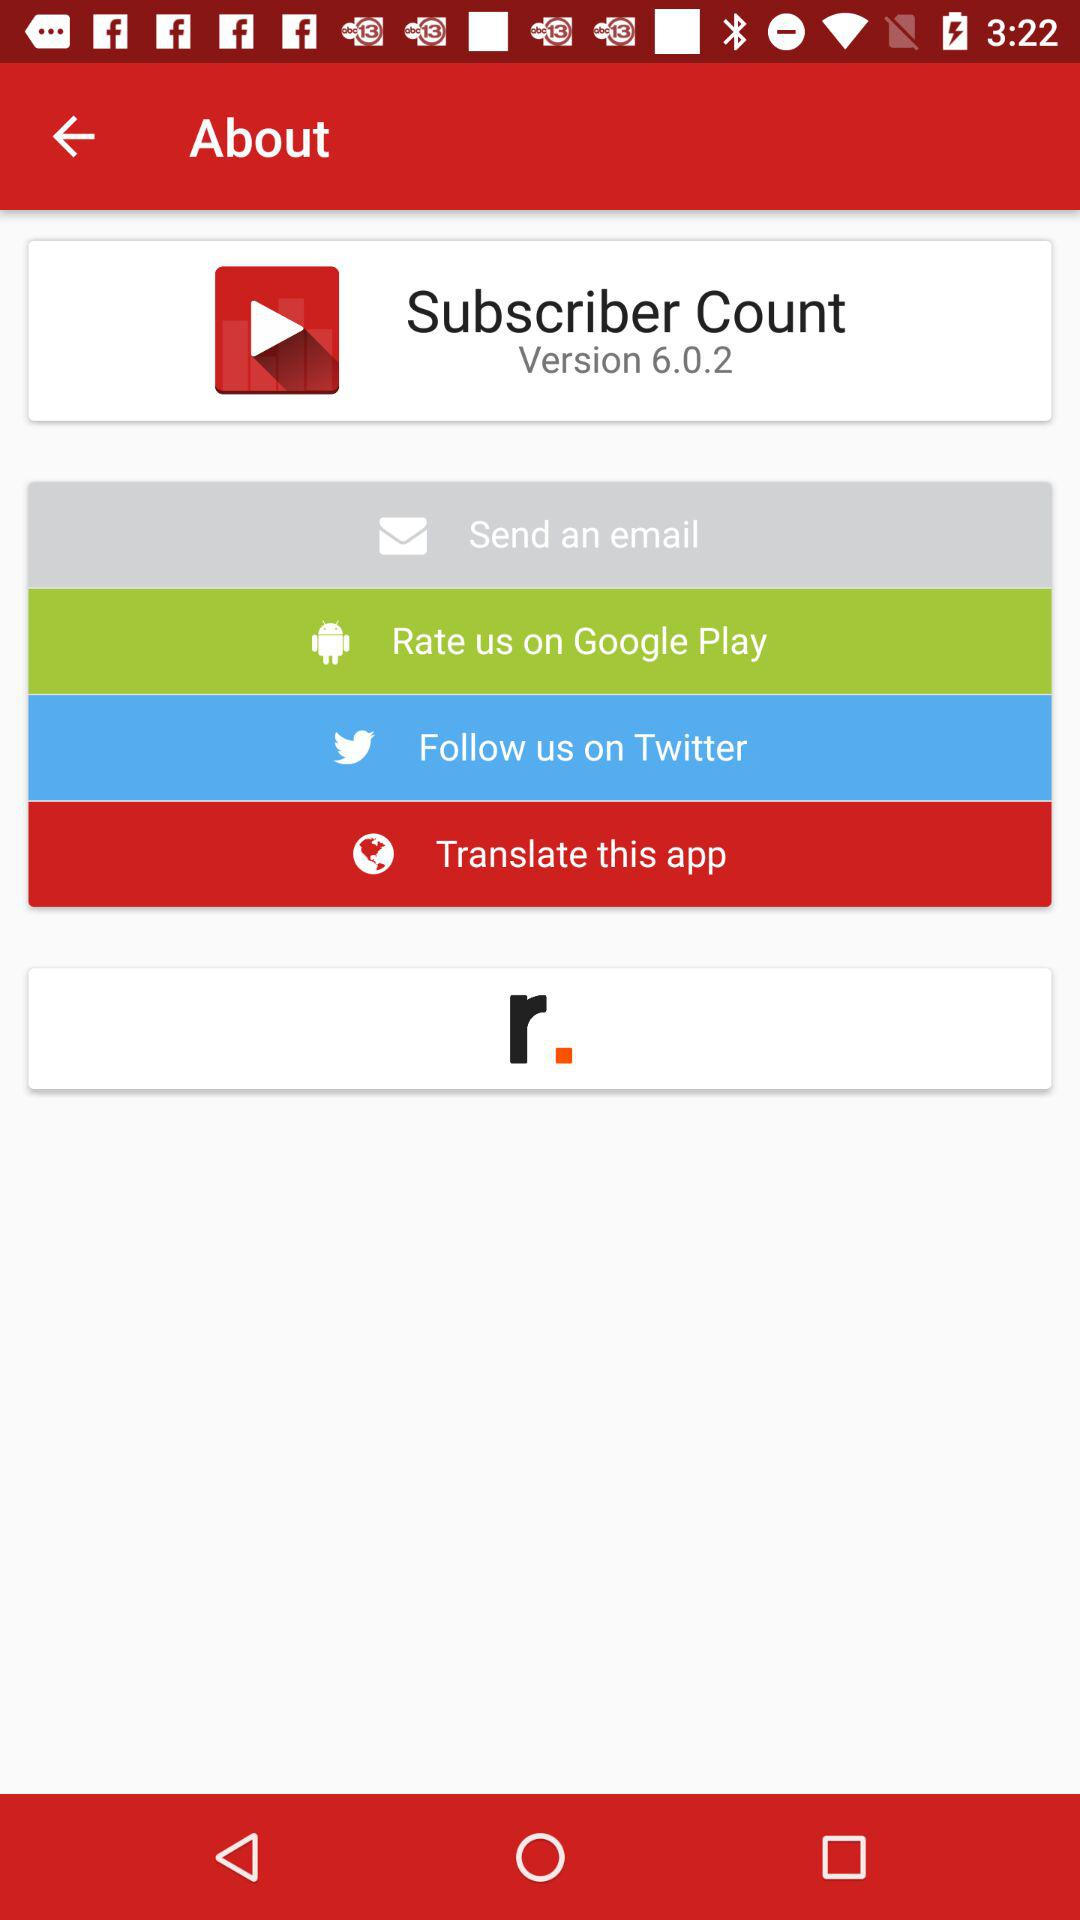Through what application can we follow? We can follow through "Twitter". 